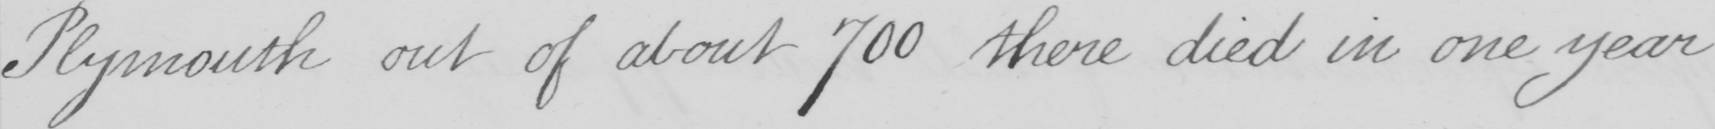Please transcribe the handwritten text in this image. Plymouth out of about 700 there died in one year 